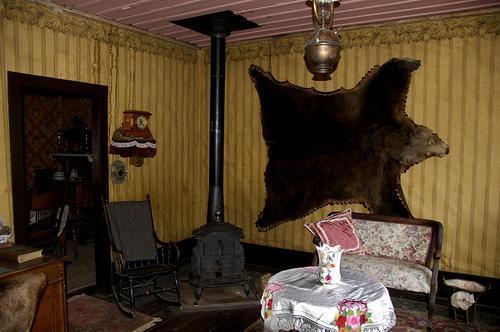How many chairs are in the photo?
Give a very brief answer. 2. How many bowls contain red foods?
Give a very brief answer. 0. 